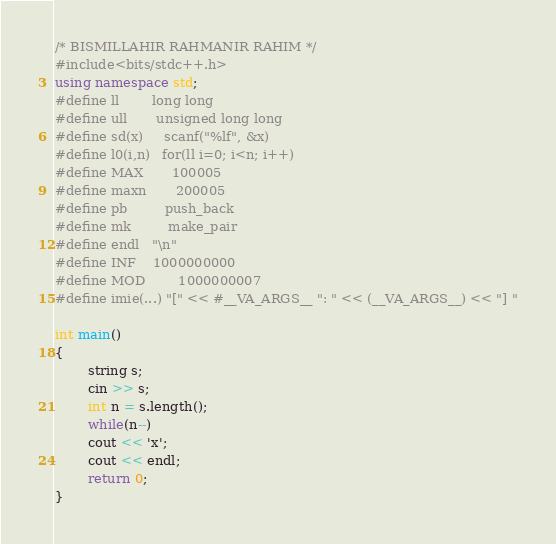<code> <loc_0><loc_0><loc_500><loc_500><_C++_>/* BISMILLAHIR RAHMANIR RAHIM */
#include<bits/stdc++.h>
using namespace std;
#define ll        long long
#define ull       unsigned long long
#define sd(x)     scanf("%lf", &x)
#define l0(i,n)   for(ll i=0; i<n; i++)
#define MAX       100005
#define maxn 	  200005
#define pb 		  push_back
#define mk 		  make_pair
#define endl	  "\n"
#define INF 	  1000000000
#define MOD		  1000000007
#define imie(...) "[" << #__VA_ARGS__ ": " << (__VA_ARGS__) << "] "

int main()
{
		string s;
		cin >> s;
		int n = s.length();
		while(n--)
		cout << 'x';
		cout << endl;
		return 0;
}
</code> 